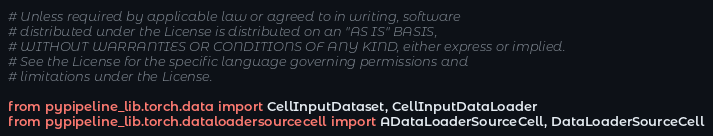<code> <loc_0><loc_0><loc_500><loc_500><_Python_># Unless required by applicable law or agreed to in writing, software
# distributed under the License is distributed on an "AS IS" BASIS,
# WITHOUT WARRANTIES OR CONDITIONS OF ANY KIND, either express or implied.
# See the License for the specific language governing permissions and
# limitations under the License.

from pypipeline_lib.torch.data import CellInputDataset, CellInputDataLoader
from pypipeline_lib.torch.dataloadersourcecell import ADataLoaderSourceCell, DataLoaderSourceCell
</code> 